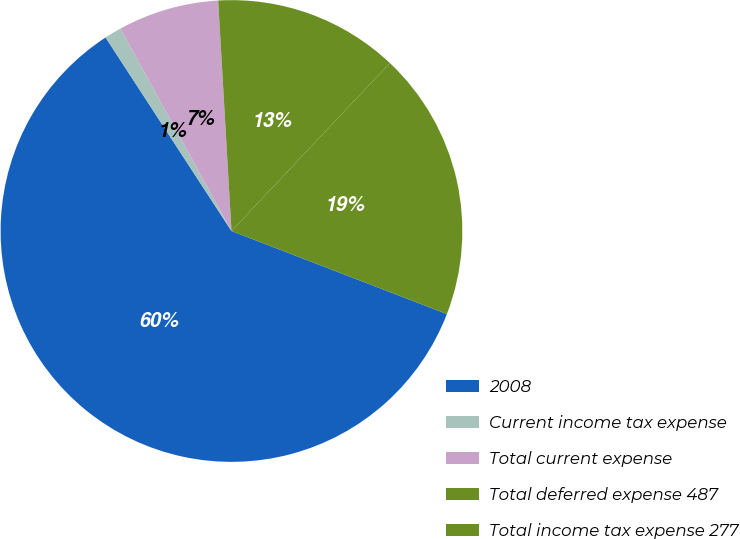Convert chart to OTSL. <chart><loc_0><loc_0><loc_500><loc_500><pie_chart><fcel>2008<fcel>Current income tax expense<fcel>Total current expense<fcel>Total deferred expense 487<fcel>Total income tax expense 277<nl><fcel>59.96%<fcel>1.19%<fcel>7.07%<fcel>12.95%<fcel>18.82%<nl></chart> 